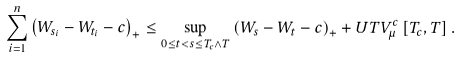<formula> <loc_0><loc_0><loc_500><loc_500>\sum _ { i = 1 } ^ { n } \left ( W _ { s _ { i } } - W _ { t _ { i } } - c \right ) _ { + } \leq \sup _ { 0 \leq t < s \leq T _ { c } \wedge T } \left ( W _ { s } - W _ { t } - c \right ) _ { + } + U T V _ { \mu } ^ { c } \left [ T _ { c } , T \right ] .</formula> 